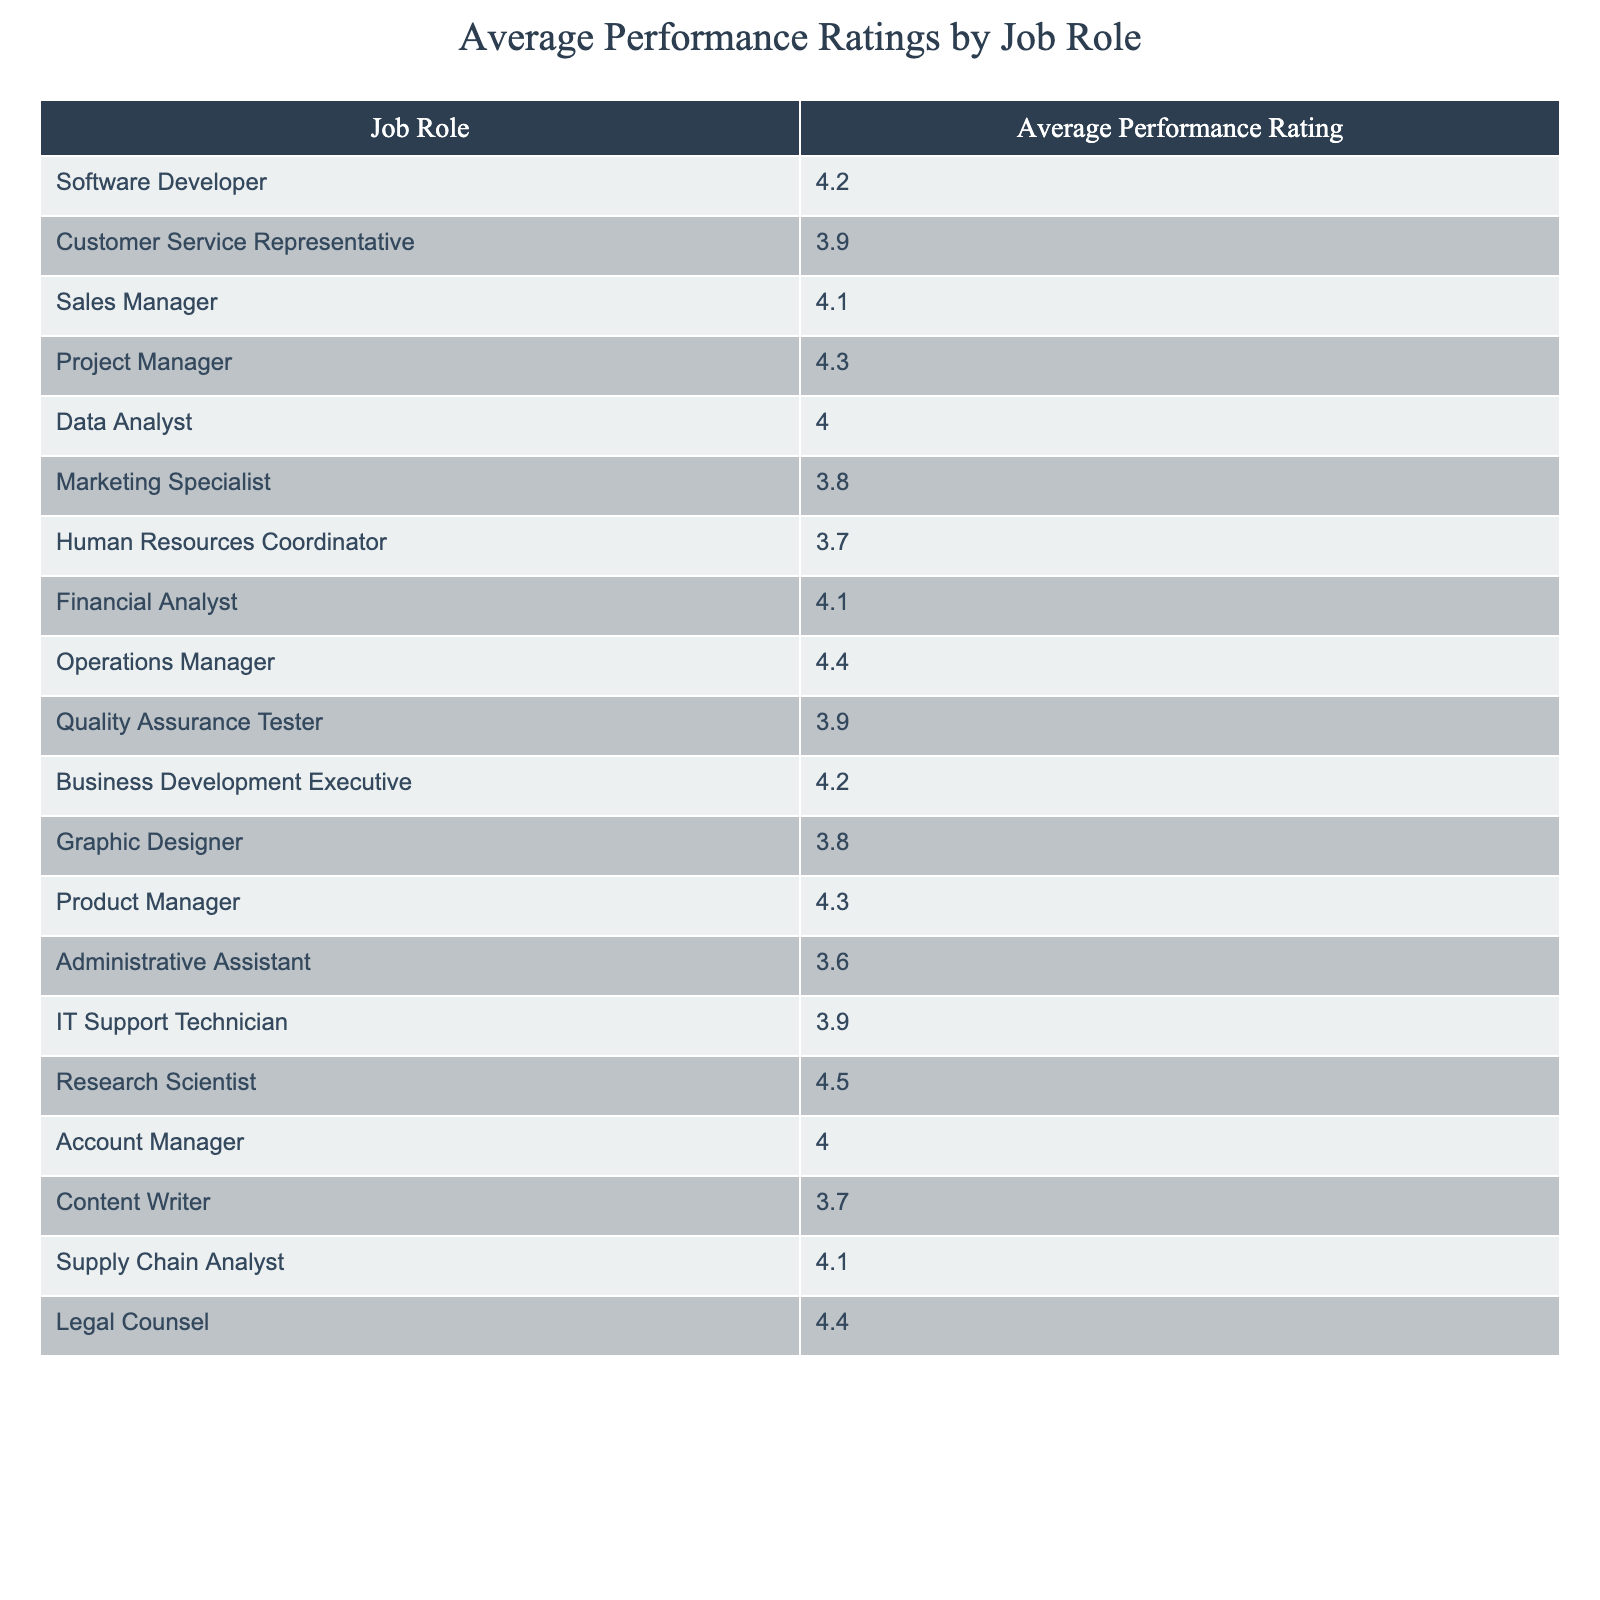What is the average performance rating for a Project Manager? The average performance rating for a Project Manager is directly listed in the table, showing a value of 4.3.
Answer: 4.3 Which job role has the lowest average performance rating? By comparing all average performance ratings listed in the table, the job role with the lowest average is Administrative Assistant, with a rating of 3.6.
Answer: 3.6 How many job roles have an average performance rating above 4.0? Counting the roles listed with ratings above 4.0, we find Software Developer, Sales Manager, Project Manager, Financial Analyst, Operations Manager, Business Development Executive, Research Scientist, Account Manager, Supply Chain Analyst, and Legal Counsel, totaling 9 job roles.
Answer: 9 Is the average performance rating for a Data Analyst higher than that for a Marketing Specialist? The average performance rating for Data Analyst is 4.0, while for Marketing Specialist it is 3.8; therefore, Data Analyst has a higher rating.
Answer: Yes What is the difference in average performance ratings between Operations Manager and Human Resources Coordinator? The average for Operations Manager is 4.4 and for Human Resources Coordinator is 3.7. The difference is 4.4 - 3.7 = 0.7.
Answer: 0.7 Which job role has a higher average rating: Graphic Designer or Content Writer? The average performance rating for Graphic Designer is 3.8, and for Content Writer, it is 3.7. Comparing these values shows that Graphic Designer has a higher rating.
Answer: Graphic Designer What is the average performance rating for the Sales Manager and Project Manager combined? The average performance ratings are 4.1 (Sales Manager) and 4.3 (Project Manager); adding these gives 4.1 + 4.3 = 8.4. To find the average, we divide by 2: 8.4 / 2 = 4.2.
Answer: 4.2 Are there more job roles with ratings above 4.0 than those below 4.0? Counting the job roles, there are 9 with ratings above 4.0 and 6 with ratings below 4.0. Since 9 is greater than 6, the statement is true.
Answer: Yes Which job roles have the same average performance rating of 4.1? The job roles that share an average performance rating of 4.1 are Financial Analyst and Supply Chain Analyst, based on the values provided in the table.
Answer: Financial Analyst, Supply Chain Analyst If the average rating for the Research Scientist is excluded, what is the new average for the remaining roles? The average rating for Research Scientist is 4.5. There are 20 job roles in total, summing the remaining ratings provides a total of 75.5 (excluding Research Scientist). To find the new average, divide 75.5 by 19 (the remaining roles): 75.5 / 19 = approximately 3.97.
Answer: Approximately 3.97 